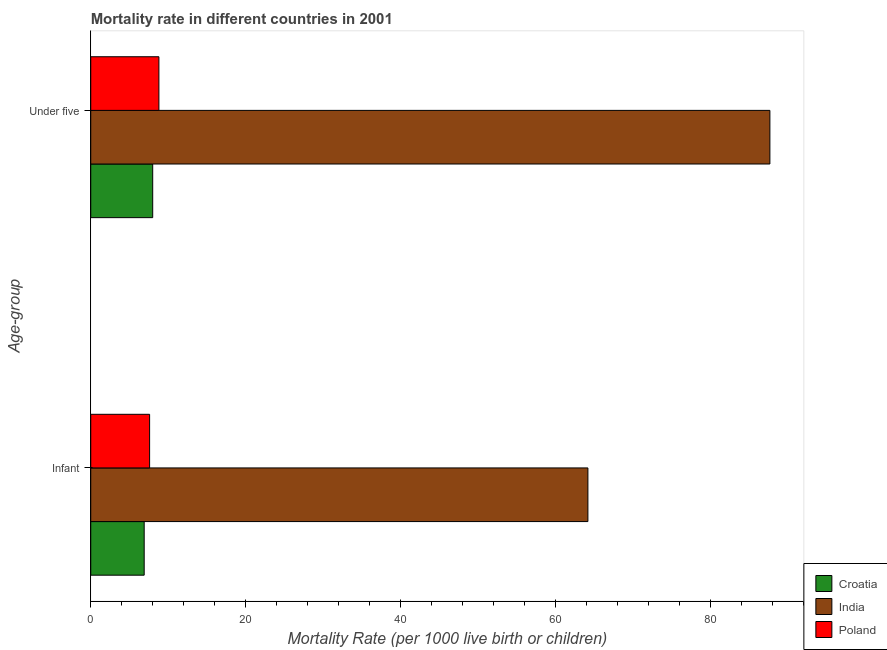How many groups of bars are there?
Keep it short and to the point. 2. How many bars are there on the 1st tick from the bottom?
Ensure brevity in your answer.  3. What is the label of the 2nd group of bars from the top?
Your response must be concise. Infant. Across all countries, what is the maximum under-5 mortality rate?
Keep it short and to the point. 87.7. In which country was the under-5 mortality rate maximum?
Your answer should be very brief. India. In which country was the infant mortality rate minimum?
Offer a terse response. Croatia. What is the total under-5 mortality rate in the graph?
Keep it short and to the point. 104.5. What is the difference between the infant mortality rate in Poland and that in India?
Provide a short and direct response. -56.6. What is the difference between the under-5 mortality rate in India and the infant mortality rate in Poland?
Your answer should be very brief. 80.1. What is the average infant mortality rate per country?
Provide a short and direct response. 26.23. What is the difference between the under-5 mortality rate and infant mortality rate in Croatia?
Ensure brevity in your answer.  1.1. What is the ratio of the under-5 mortality rate in Croatia to that in India?
Keep it short and to the point. 0.09. What does the 1st bar from the top in Under five represents?
Make the answer very short. Poland. What does the 1st bar from the bottom in Infant represents?
Ensure brevity in your answer.  Croatia. How many bars are there?
Give a very brief answer. 6. How many countries are there in the graph?
Offer a very short reply. 3. What is the difference between two consecutive major ticks on the X-axis?
Ensure brevity in your answer.  20. Does the graph contain grids?
Provide a succinct answer. No. How many legend labels are there?
Give a very brief answer. 3. What is the title of the graph?
Your answer should be compact. Mortality rate in different countries in 2001. Does "Qatar" appear as one of the legend labels in the graph?
Offer a very short reply. No. What is the label or title of the X-axis?
Your response must be concise. Mortality Rate (per 1000 live birth or children). What is the label or title of the Y-axis?
Give a very brief answer. Age-group. What is the Mortality Rate (per 1000 live birth or children) of India in Infant?
Keep it short and to the point. 64.2. What is the Mortality Rate (per 1000 live birth or children) in India in Under five?
Offer a terse response. 87.7. Across all Age-group, what is the maximum Mortality Rate (per 1000 live birth or children) of India?
Offer a terse response. 87.7. Across all Age-group, what is the minimum Mortality Rate (per 1000 live birth or children) of India?
Your response must be concise. 64.2. What is the total Mortality Rate (per 1000 live birth or children) of Croatia in the graph?
Make the answer very short. 14.9. What is the total Mortality Rate (per 1000 live birth or children) in India in the graph?
Offer a terse response. 151.9. What is the difference between the Mortality Rate (per 1000 live birth or children) in India in Infant and that in Under five?
Make the answer very short. -23.5. What is the difference between the Mortality Rate (per 1000 live birth or children) in Croatia in Infant and the Mortality Rate (per 1000 live birth or children) in India in Under five?
Provide a succinct answer. -80.8. What is the difference between the Mortality Rate (per 1000 live birth or children) in Croatia in Infant and the Mortality Rate (per 1000 live birth or children) in Poland in Under five?
Provide a succinct answer. -1.9. What is the difference between the Mortality Rate (per 1000 live birth or children) in India in Infant and the Mortality Rate (per 1000 live birth or children) in Poland in Under five?
Provide a succinct answer. 55.4. What is the average Mortality Rate (per 1000 live birth or children) of Croatia per Age-group?
Ensure brevity in your answer.  7.45. What is the average Mortality Rate (per 1000 live birth or children) of India per Age-group?
Provide a short and direct response. 75.95. What is the difference between the Mortality Rate (per 1000 live birth or children) of Croatia and Mortality Rate (per 1000 live birth or children) of India in Infant?
Your answer should be very brief. -57.3. What is the difference between the Mortality Rate (per 1000 live birth or children) in Croatia and Mortality Rate (per 1000 live birth or children) in Poland in Infant?
Give a very brief answer. -0.7. What is the difference between the Mortality Rate (per 1000 live birth or children) in India and Mortality Rate (per 1000 live birth or children) in Poland in Infant?
Your response must be concise. 56.6. What is the difference between the Mortality Rate (per 1000 live birth or children) in Croatia and Mortality Rate (per 1000 live birth or children) in India in Under five?
Provide a succinct answer. -79.7. What is the difference between the Mortality Rate (per 1000 live birth or children) of India and Mortality Rate (per 1000 live birth or children) of Poland in Under five?
Make the answer very short. 78.9. What is the ratio of the Mortality Rate (per 1000 live birth or children) in Croatia in Infant to that in Under five?
Provide a short and direct response. 0.86. What is the ratio of the Mortality Rate (per 1000 live birth or children) of India in Infant to that in Under five?
Provide a succinct answer. 0.73. What is the ratio of the Mortality Rate (per 1000 live birth or children) in Poland in Infant to that in Under five?
Your response must be concise. 0.86. What is the difference between the highest and the second highest Mortality Rate (per 1000 live birth or children) of India?
Your answer should be very brief. 23.5. What is the difference between the highest and the second highest Mortality Rate (per 1000 live birth or children) in Poland?
Your answer should be compact. 1.2. What is the difference between the highest and the lowest Mortality Rate (per 1000 live birth or children) in Croatia?
Your answer should be compact. 1.1. What is the difference between the highest and the lowest Mortality Rate (per 1000 live birth or children) in India?
Make the answer very short. 23.5. 